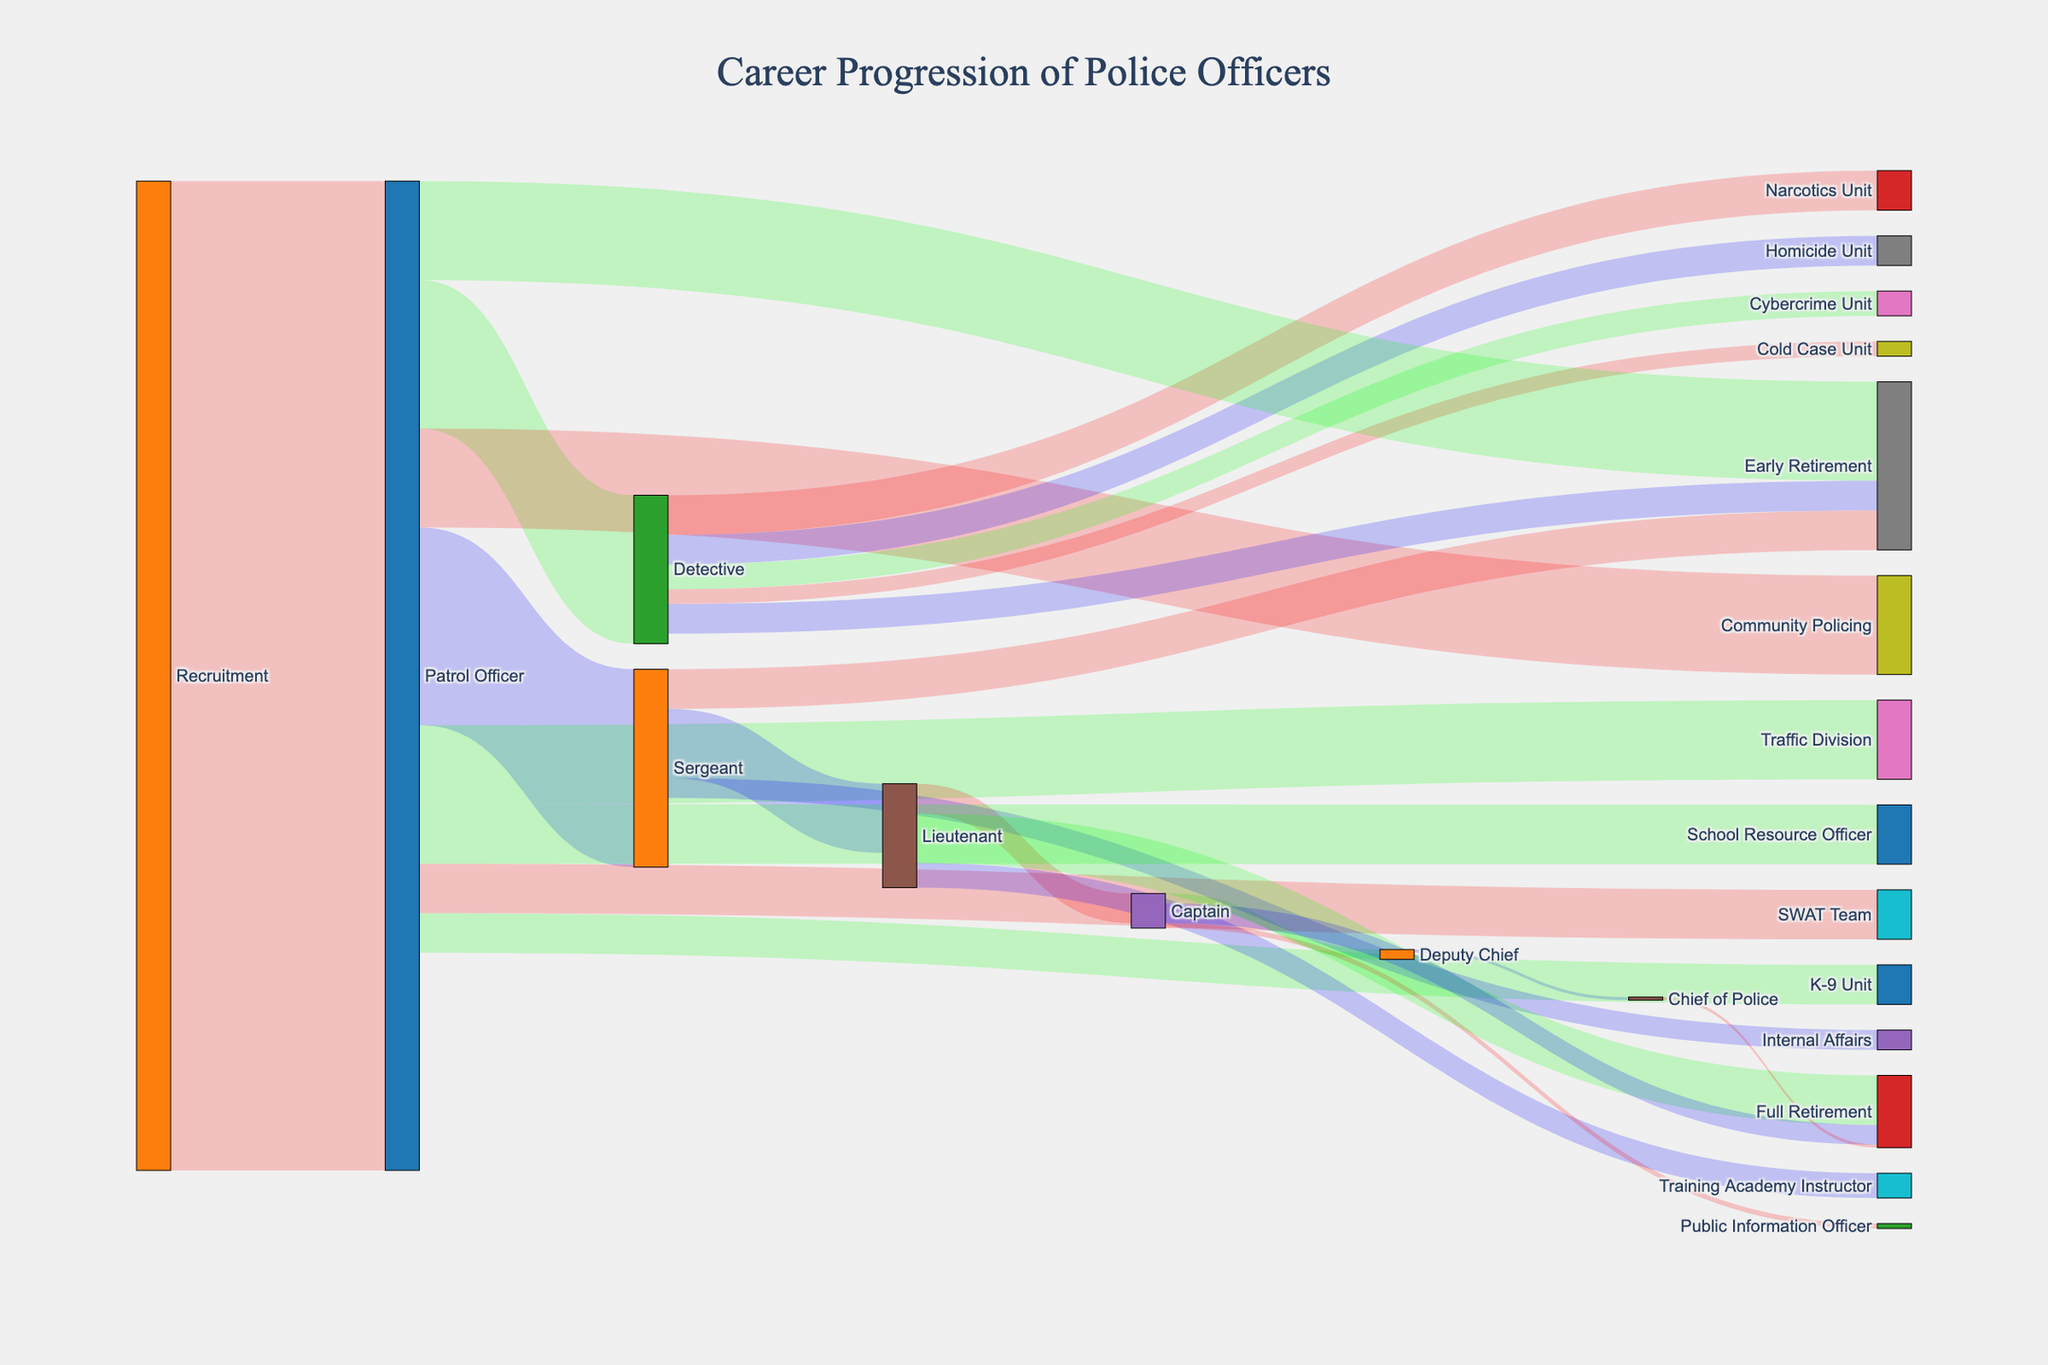What's the title of the figure? The title is usually displayed at the top of the figure. In this case, it reads "Career Progression of Police Officers."
Answer: Career Progression of Police Officers What role has the highest number of recruits from the recruitment stage? By looking at the size of the flows originating from the Recruitment source node, the largest flow goes to Patrol Officer.
Answer: Patrol Officer How many recruits become Detectives? The flow from Patrol Officer to Detective indicates the number becoming Detectives, which is marked as 150.
Answer: 150 Which specialized unit has the fewest officers transferred from the Detective role? Check the flows from Detective to various specialized units and find the smallest value. The Cold Case Unit has the fewest at 15.
Answer: Cold Case Unit What is the total number of officers who take early retirement from all roles combined? Add the values of flows to Early Retirement from all roles: Patrol Officer (100), Detective (30), and Sergeant (40). So, 100 + 30 + 40 = 170.
Answer: 170 How many officers progress from Sergeant to Lieutenant? Identify the flow from Sergeant to Lieutenant, which is marked with the value of 70.
Answer: 70 Which role has the maximum number of officers transitioning into Full Retirement? Look for the largest flow ending in Full Retirement. Lieutenant transitions 50 officers, which is the highest.
Answer: Lieutenant How many officers go from Patrol Officer to Community Policing? The flow from Patrol Officer to Community Policing shows the value of 100.
Answer: 100 Compare the number of officers in the Traffic Division and the SWAT Team. Which division has more officers, and by how many? Check the flows from Patrol Officer to both Traffic Division (80) and SWAT Team (50). Subtract the numbers: 80 - 50 = 30. The Traffic Division has 30 more officers.
Answer: Traffic Division, 30 more How many officers reach the role of Chief of Police? The flow to Chief of Police shows a value of 3.
Answer: 3 